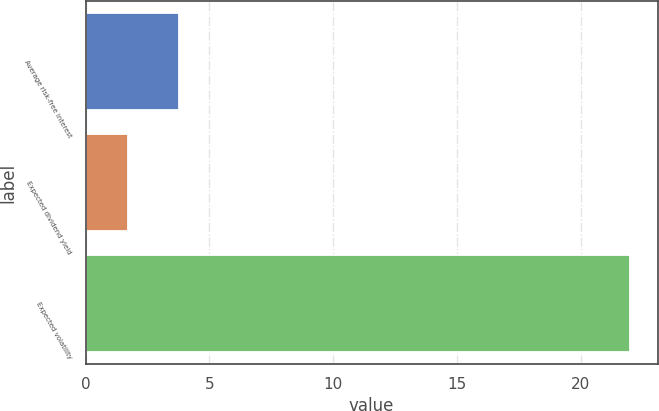Convert chart. <chart><loc_0><loc_0><loc_500><loc_500><bar_chart><fcel>Average risk-free interest<fcel>Expected dividend yield<fcel>Expected volatility<nl><fcel>3.75<fcel>1.72<fcel>22<nl></chart> 